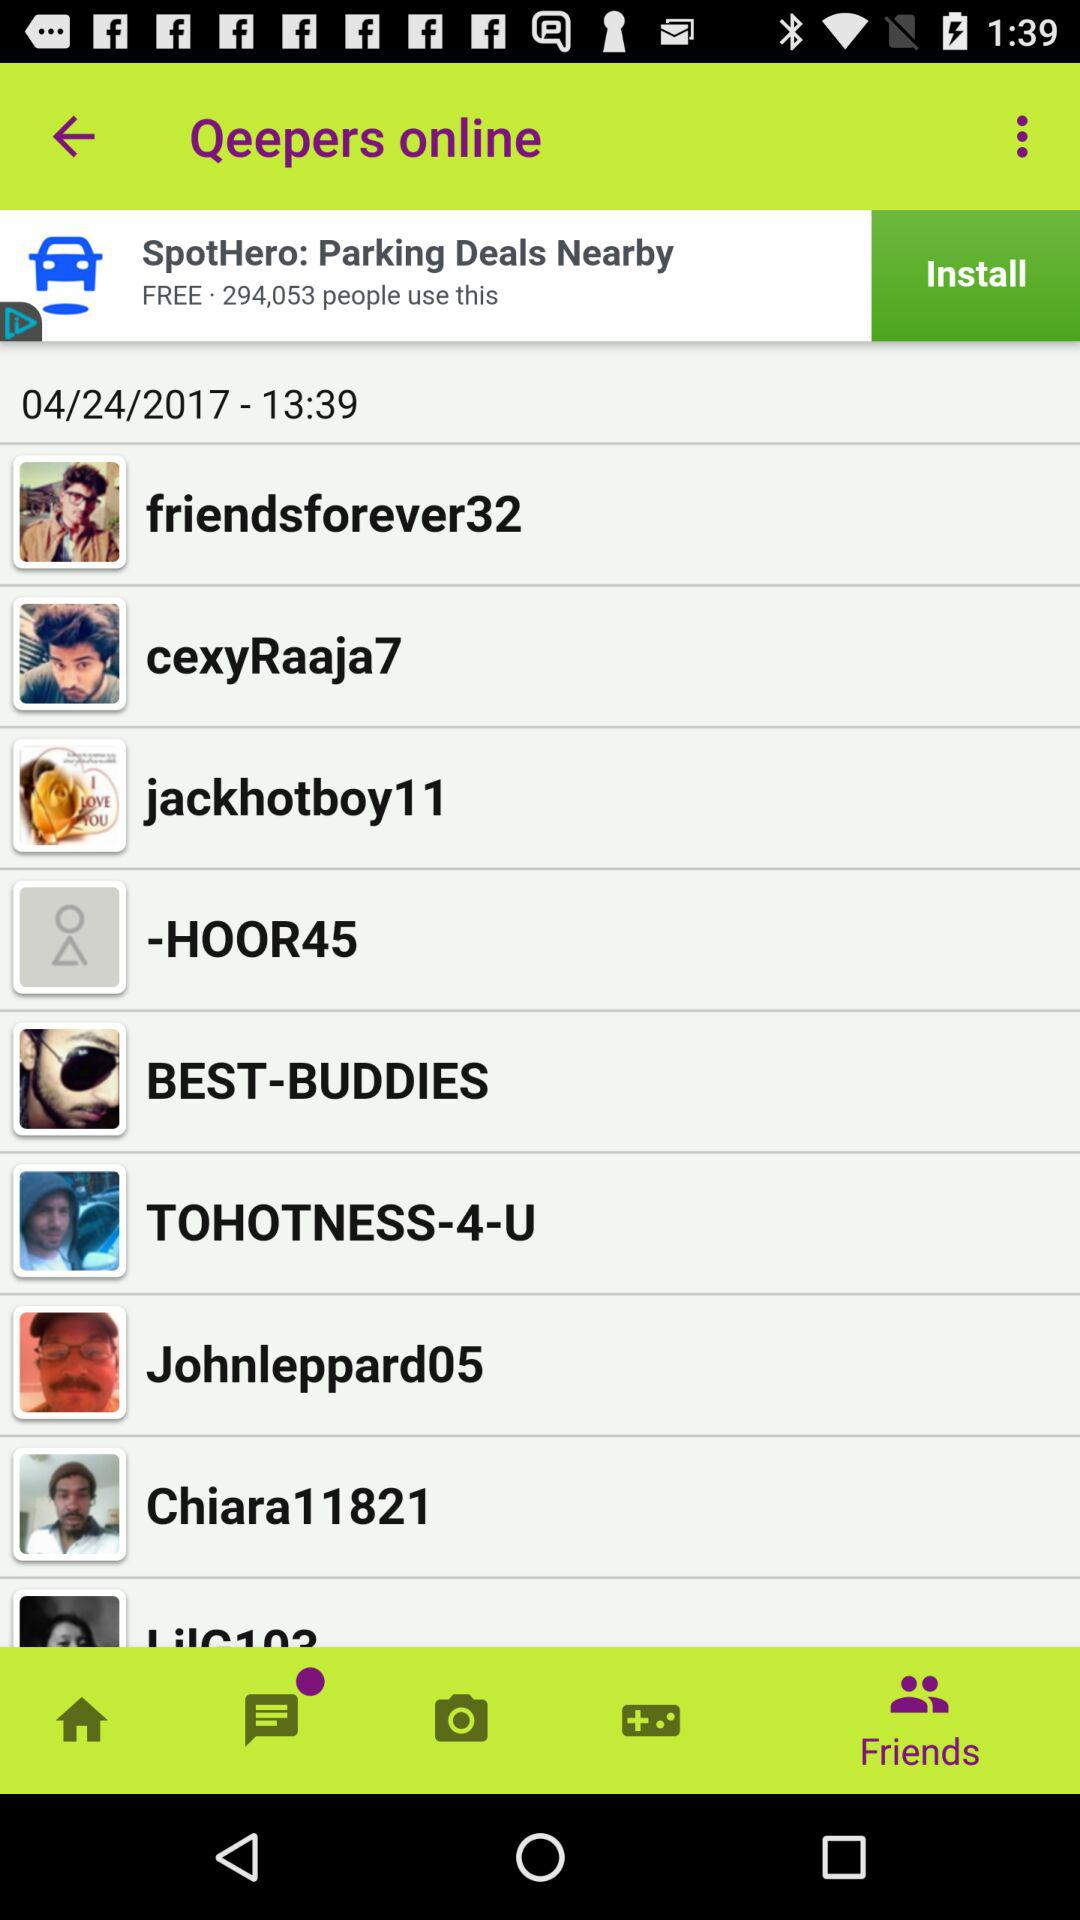What is the mentioned date and time? The mentioned date and time is April 24, 2017 at 13:39. 